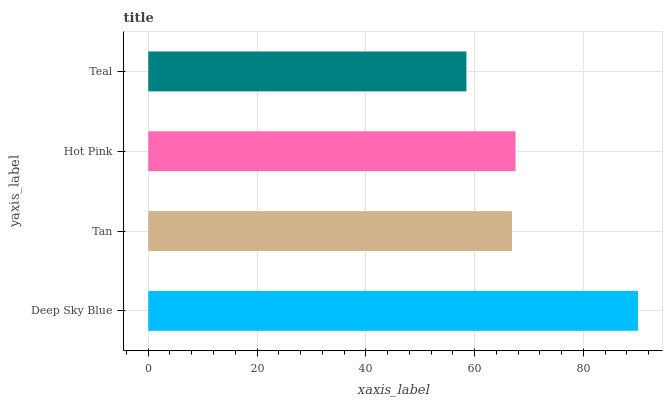Is Teal the minimum?
Answer yes or no. Yes. Is Deep Sky Blue the maximum?
Answer yes or no. Yes. Is Tan the minimum?
Answer yes or no. No. Is Tan the maximum?
Answer yes or no. No. Is Deep Sky Blue greater than Tan?
Answer yes or no. Yes. Is Tan less than Deep Sky Blue?
Answer yes or no. Yes. Is Tan greater than Deep Sky Blue?
Answer yes or no. No. Is Deep Sky Blue less than Tan?
Answer yes or no. No. Is Hot Pink the high median?
Answer yes or no. Yes. Is Tan the low median?
Answer yes or no. Yes. Is Tan the high median?
Answer yes or no. No. Is Deep Sky Blue the low median?
Answer yes or no. No. 